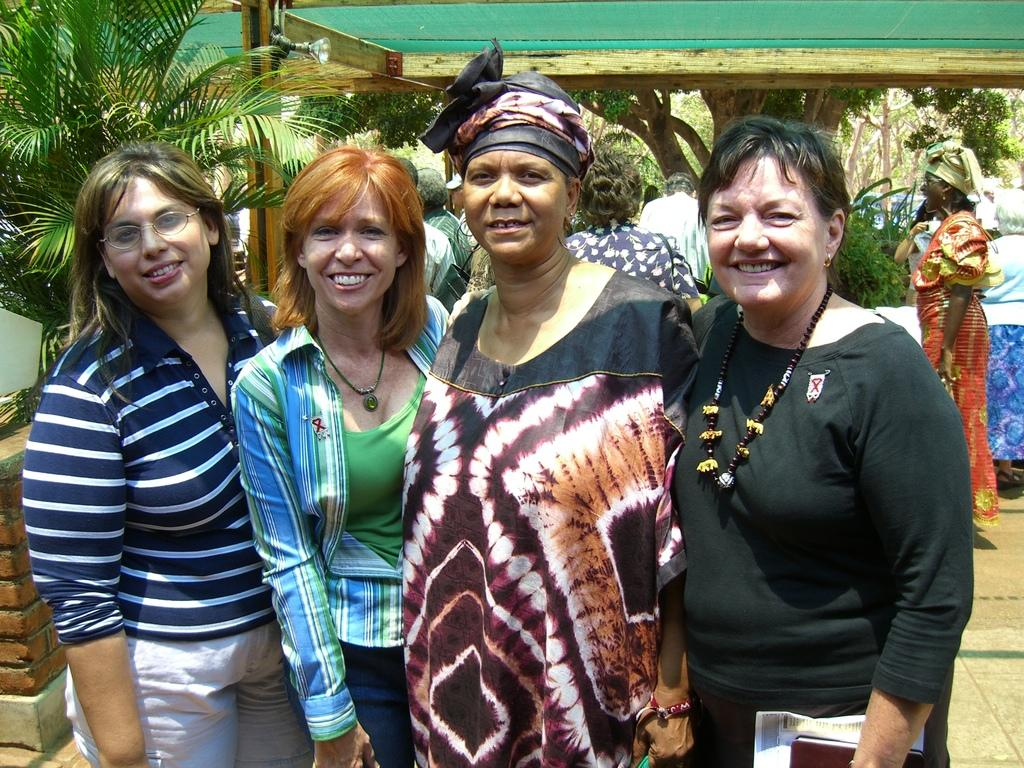How many people are present in the image? There are four persons in the image. What is the facial expression of the people in the image? The persons are smiling. What can be seen in the background of the image? There is a wall, a light, people, a floor, and trees in the background of the image. What type of wrist accessory is visible on the person in the image? There is no wrist accessory visible on any person in the image. What is the current status of the trees in the background of the image? The provided facts do not mention any specific status of the trees, only that they are present in the background. 